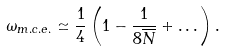<formula> <loc_0><loc_0><loc_500><loc_500>\omega _ { m . c . e . } \simeq \frac { 1 } { 4 } \left ( 1 - \frac { 1 } { 8 \overline { N } } + \dots \right ) .</formula> 